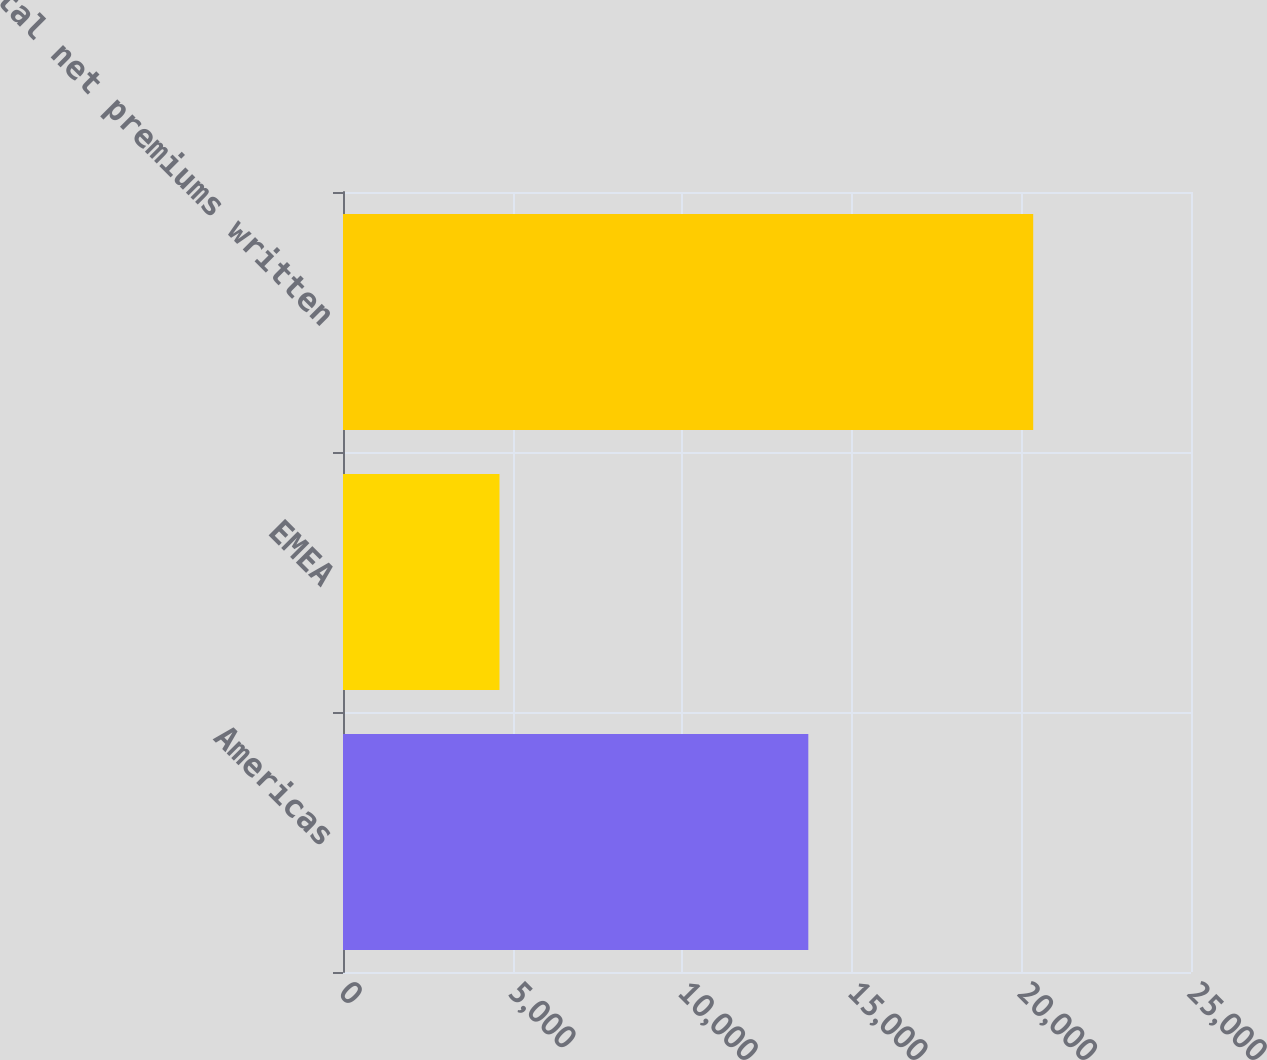<chart> <loc_0><loc_0><loc_500><loc_500><bar_chart><fcel>Americas<fcel>EMEA<fcel>Total net premiums written<nl><fcel>13718<fcel>4614<fcel>20348<nl></chart> 